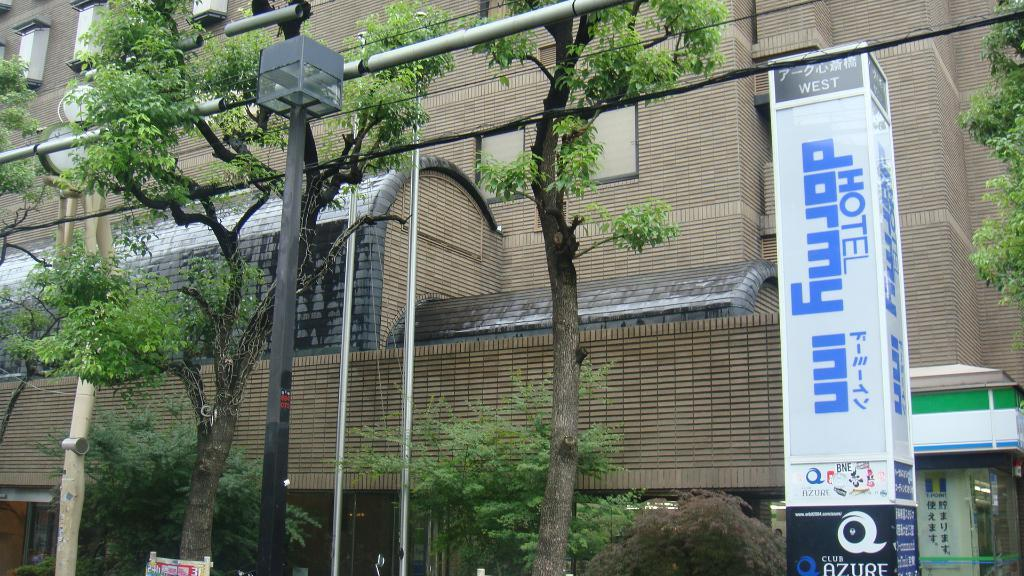What structures can be seen in the image? There are poles in the image. What type of vegetation is present in the image? There are trees with green color in the image. What is the object with writing or graphics in the image? There is a board in the image. What type of building can be seen in the background? In the background, there is a building with a brown color. Can you see any arms holding the poles in the image? There are no arms or people holding the poles in the image. What type of berry can be seen growing on the trees in the image? There are no berries visible on the trees in the image; they are simply green trees. 